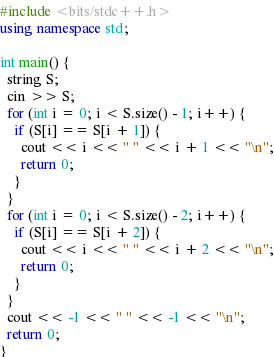Convert code to text. <code><loc_0><loc_0><loc_500><loc_500><_C++_>#include <bits/stdc++.h>
using namespace std;

int main() {
  string S;
  cin >> S;
  for (int i = 0; i < S.size() - 1; i++) {
    if (S[i] == S[i + 1]) {
      cout << i << " " << i + 1 << "\n";
      return 0;
    }
  }
  for (int i = 0; i < S.size() - 2; i++) {
    if (S[i] == S[i + 2]) {
      cout << i << " " << i + 2 << "\n";
      return 0;
    }
  }
  cout << -1 << " " << -1 << "\n";
  return 0;
}</code> 